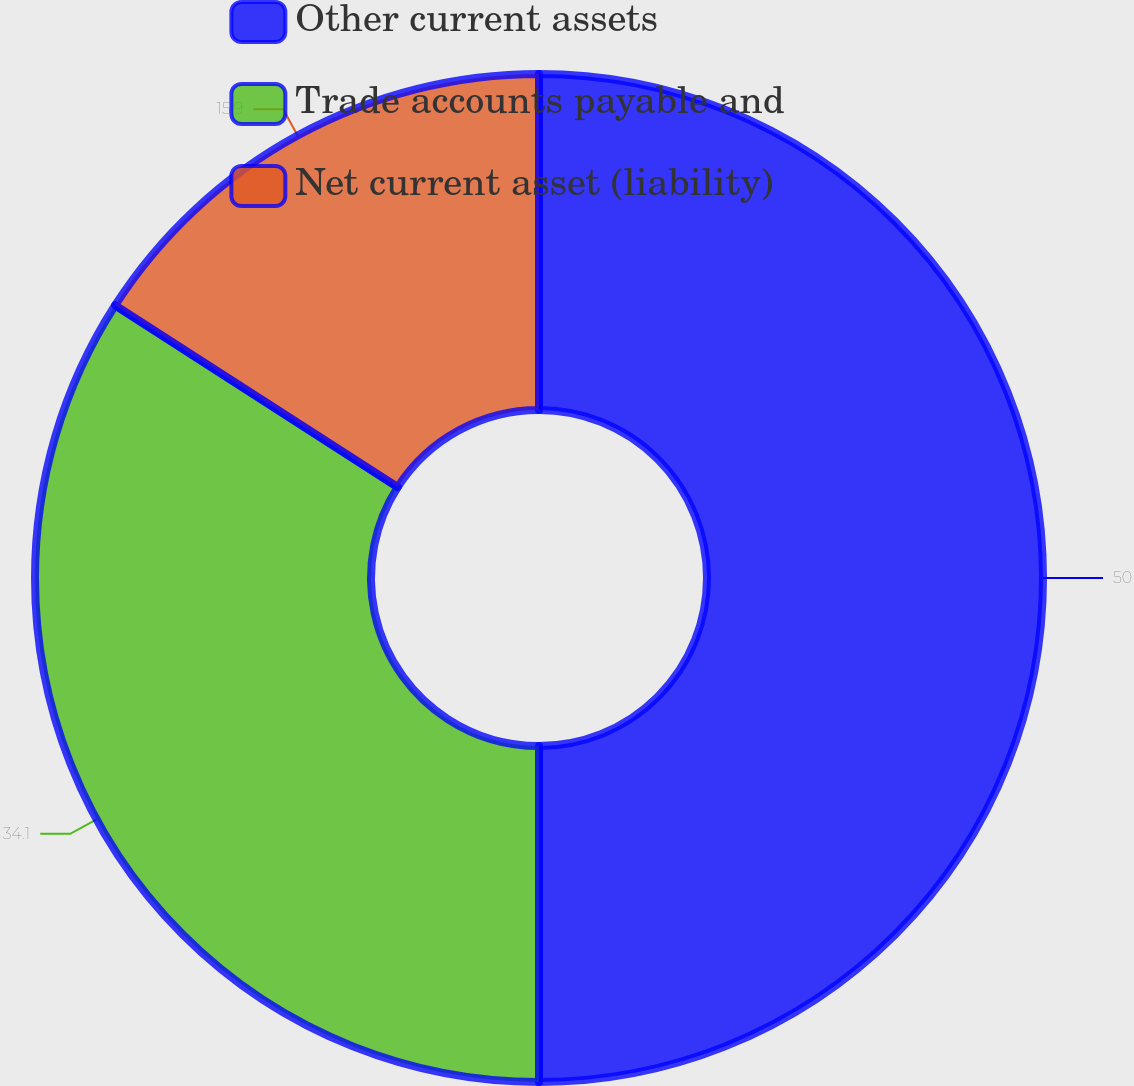<chart> <loc_0><loc_0><loc_500><loc_500><pie_chart><fcel>Other current assets<fcel>Trade accounts payable and<fcel>Net current asset (liability)<nl><fcel>50.0%<fcel>34.1%<fcel>15.9%<nl></chart> 